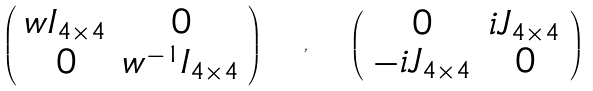Convert formula to latex. <formula><loc_0><loc_0><loc_500><loc_500>\left ( \begin{array} { c c } w I _ { 4 \times 4 } & 0 \\ 0 & w ^ { - 1 } I _ { 4 \times 4 } \end{array} \right ) \quad , \quad \left ( \begin{array} { c c } 0 & i J _ { 4 \times 4 } \\ - i J _ { 4 \times 4 } & 0 \end{array} \right )</formula> 